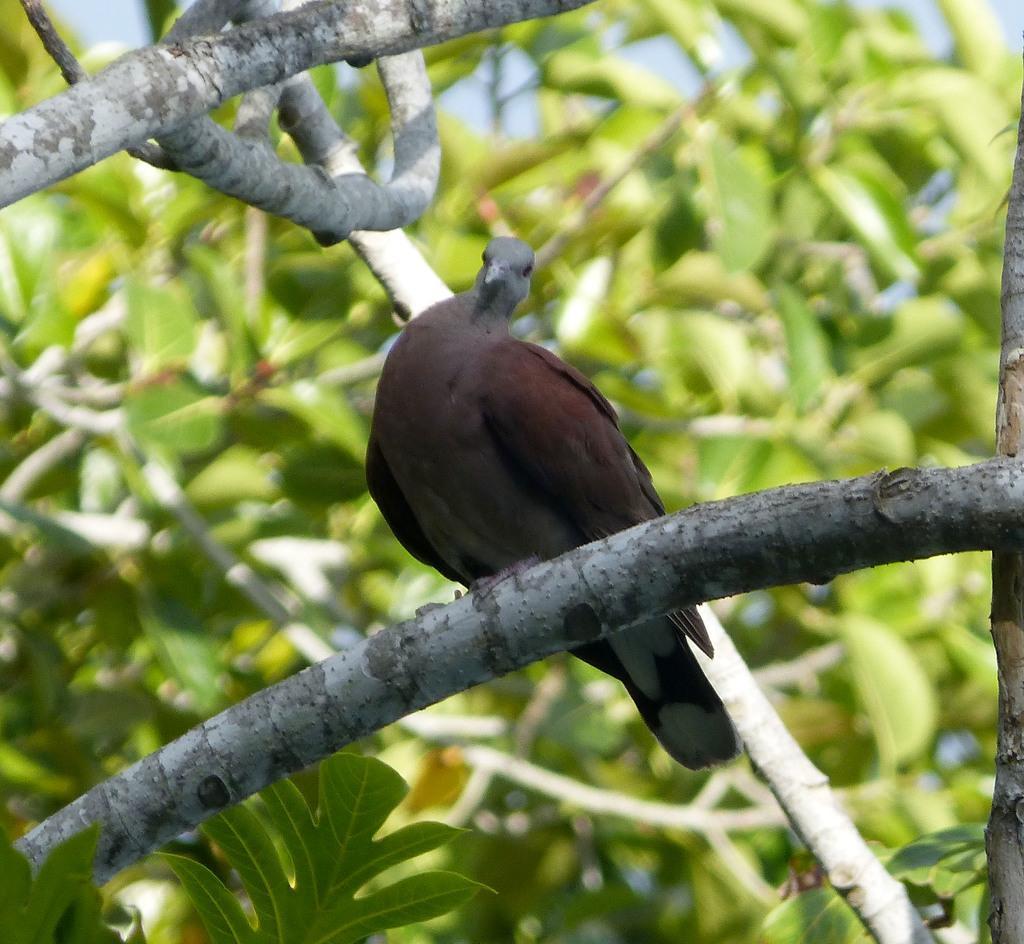In one or two sentences, can you explain what this image depicts? In this image we can see a bird sitting on the branch and in the background we can see some plants. 